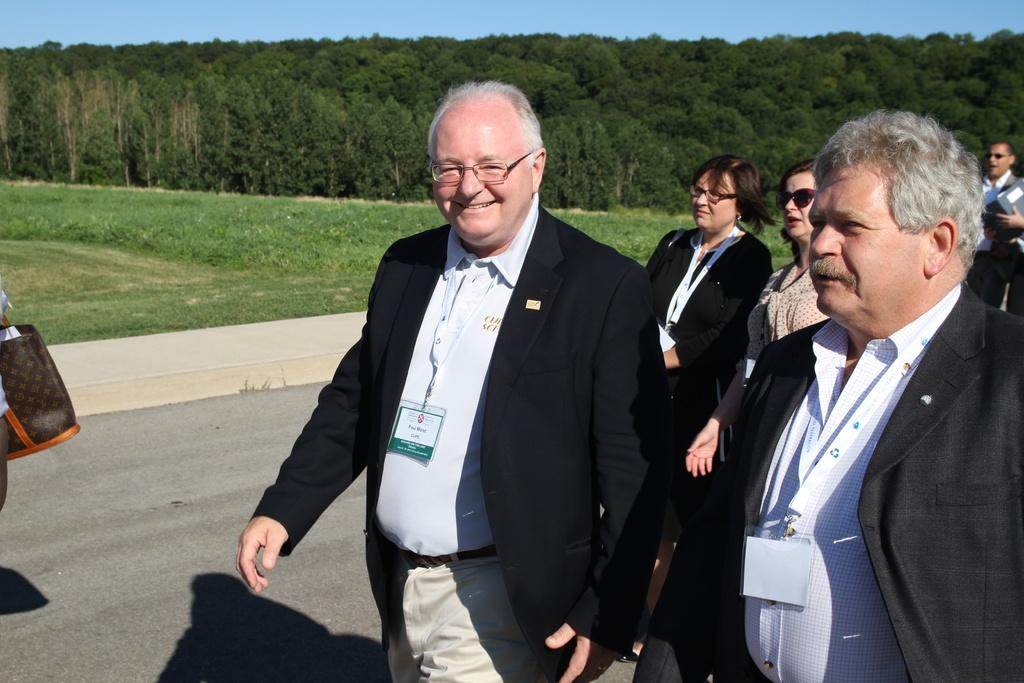What are the people in the image doing? The people in the image are walking on the road. What type of vegetation is present on the left side of the image? There is grass on the surface on the left side of the image. What can be seen in the background of the image? There are trees and the sky visible in the background of the image. What type of credit card is being used by the trees in the image? There are no credit cards or trees using credit cards present in the image. 